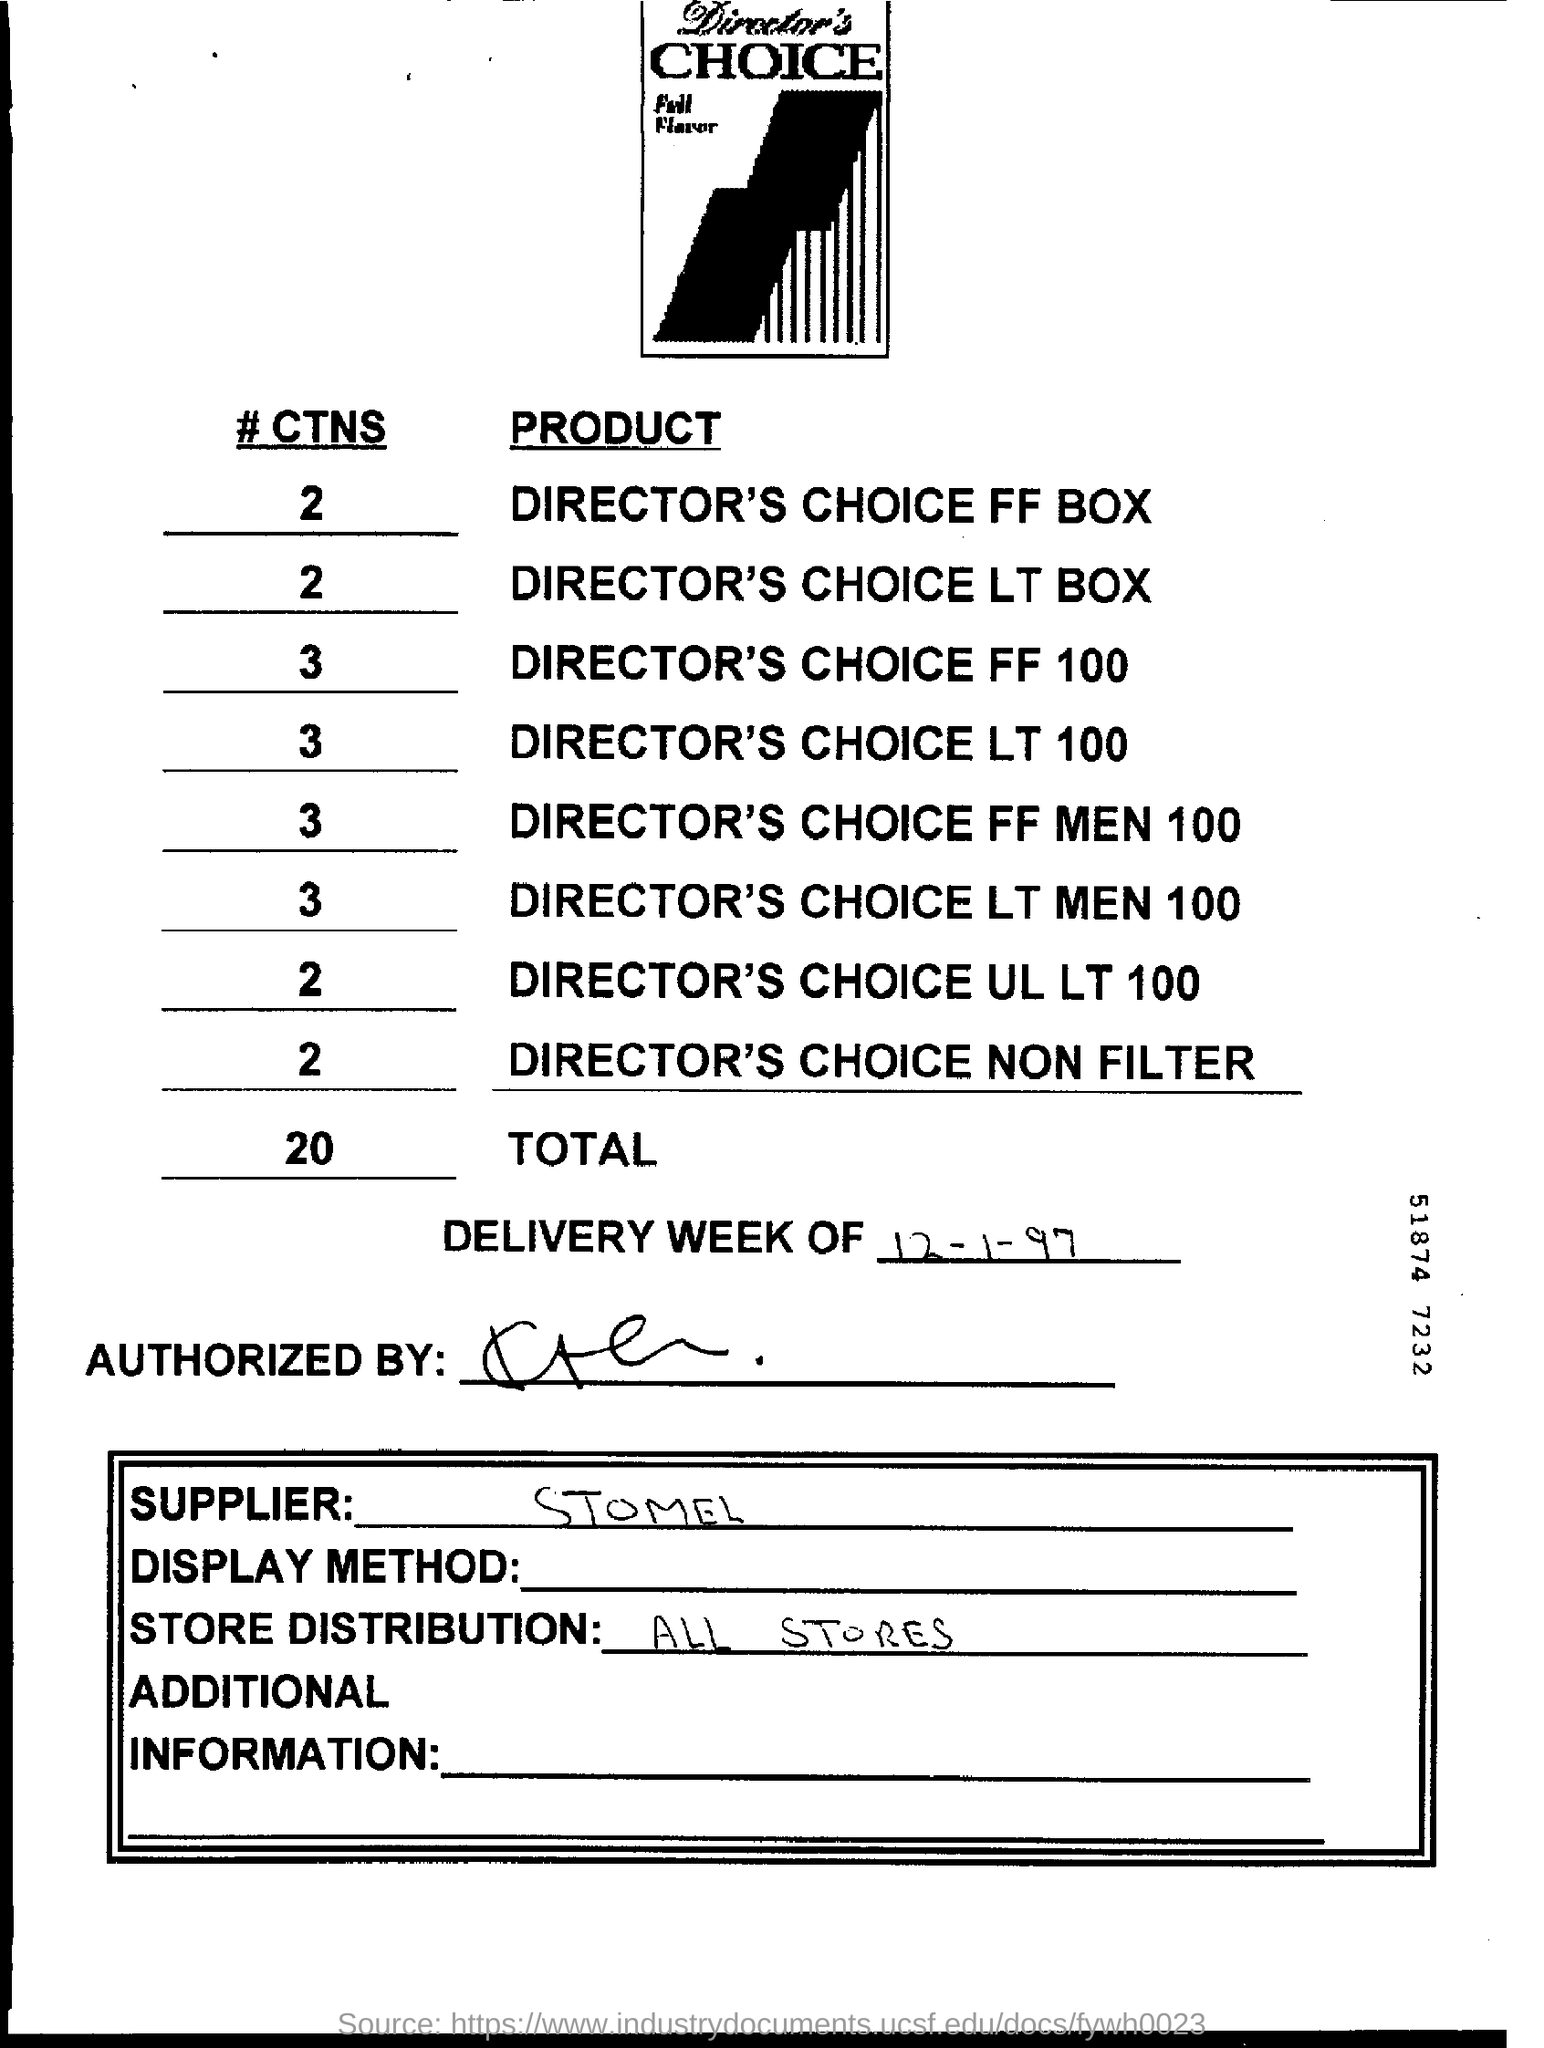Draw attention to some important aspects in this diagram. What is the total of #CTN?" is a question that asks for an answer related to the number 20. What is mentioned in store distribution? It encompasses all stores. 